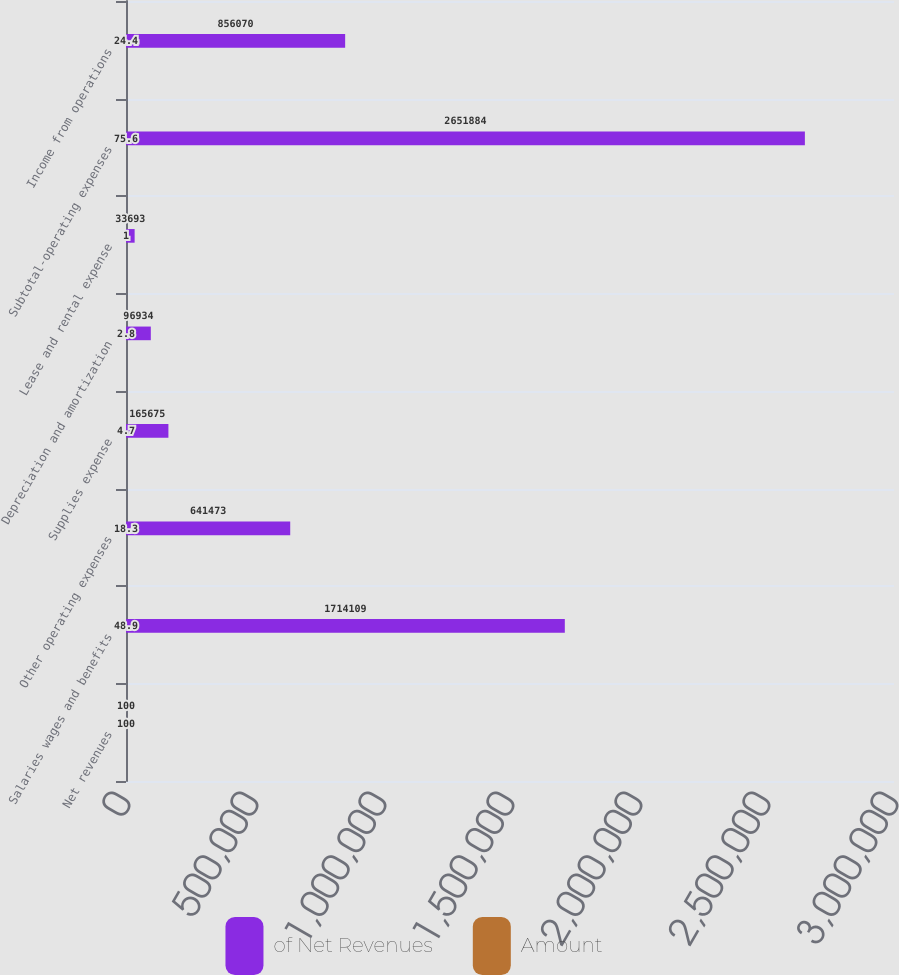Convert chart to OTSL. <chart><loc_0><loc_0><loc_500><loc_500><stacked_bar_chart><ecel><fcel>Net revenues<fcel>Salaries wages and benefits<fcel>Other operating expenses<fcel>Supplies expense<fcel>Depreciation and amortization<fcel>Lease and rental expense<fcel>Subtotal-operating expenses<fcel>Income from operations<nl><fcel>of Net Revenues<fcel>100<fcel>1.71411e+06<fcel>641473<fcel>165675<fcel>96934<fcel>33693<fcel>2.65188e+06<fcel>856070<nl><fcel>Amount<fcel>100<fcel>48.9<fcel>18.3<fcel>4.7<fcel>2.8<fcel>1<fcel>75.6<fcel>24.4<nl></chart> 